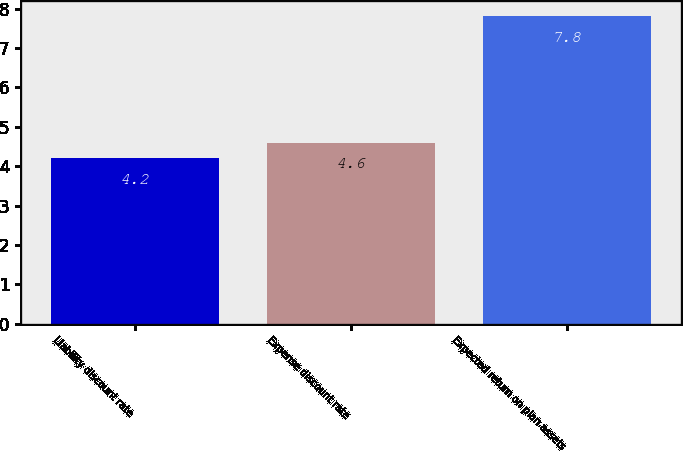Convert chart. <chart><loc_0><loc_0><loc_500><loc_500><bar_chart><fcel>Liability discount rate<fcel>Expense discount rate<fcel>Expected return on plan assets<nl><fcel>4.2<fcel>4.6<fcel>7.8<nl></chart> 